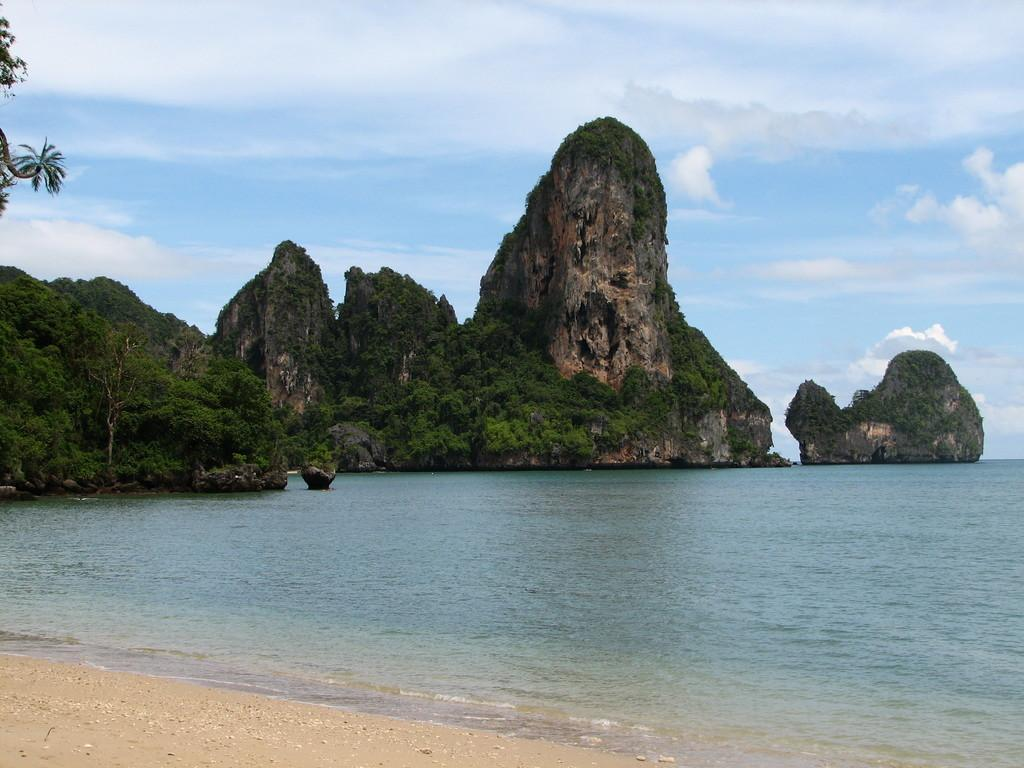What is the primary element visible in the image? There is water in the image. What can be seen in the distance behind the water? There are trees and rocks in the background of the image. What part of the natural environment is visible in the image? The sky is visible in the background of the image. How many boys are pointing at the water in the image? There are no boys present in the image, so it is not possible to answer that question. 